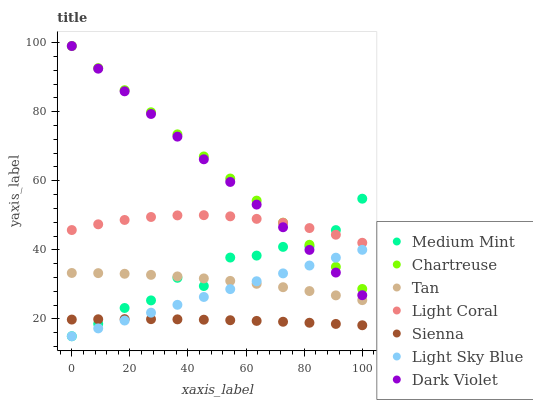Does Sienna have the minimum area under the curve?
Answer yes or no. Yes. Does Chartreuse have the maximum area under the curve?
Answer yes or no. Yes. Does Dark Violet have the minimum area under the curve?
Answer yes or no. No. Does Dark Violet have the maximum area under the curve?
Answer yes or no. No. Is Chartreuse the smoothest?
Answer yes or no. Yes. Is Medium Mint the roughest?
Answer yes or no. Yes. Is Sienna the smoothest?
Answer yes or no. No. Is Sienna the roughest?
Answer yes or no. No. Does Medium Mint have the lowest value?
Answer yes or no. Yes. Does Sienna have the lowest value?
Answer yes or no. No. Does Chartreuse have the highest value?
Answer yes or no. Yes. Does Sienna have the highest value?
Answer yes or no. No. Is Sienna less than Light Coral?
Answer yes or no. Yes. Is Light Coral greater than Sienna?
Answer yes or no. Yes. Does Medium Mint intersect Dark Violet?
Answer yes or no. Yes. Is Medium Mint less than Dark Violet?
Answer yes or no. No. Is Medium Mint greater than Dark Violet?
Answer yes or no. No. Does Sienna intersect Light Coral?
Answer yes or no. No. 